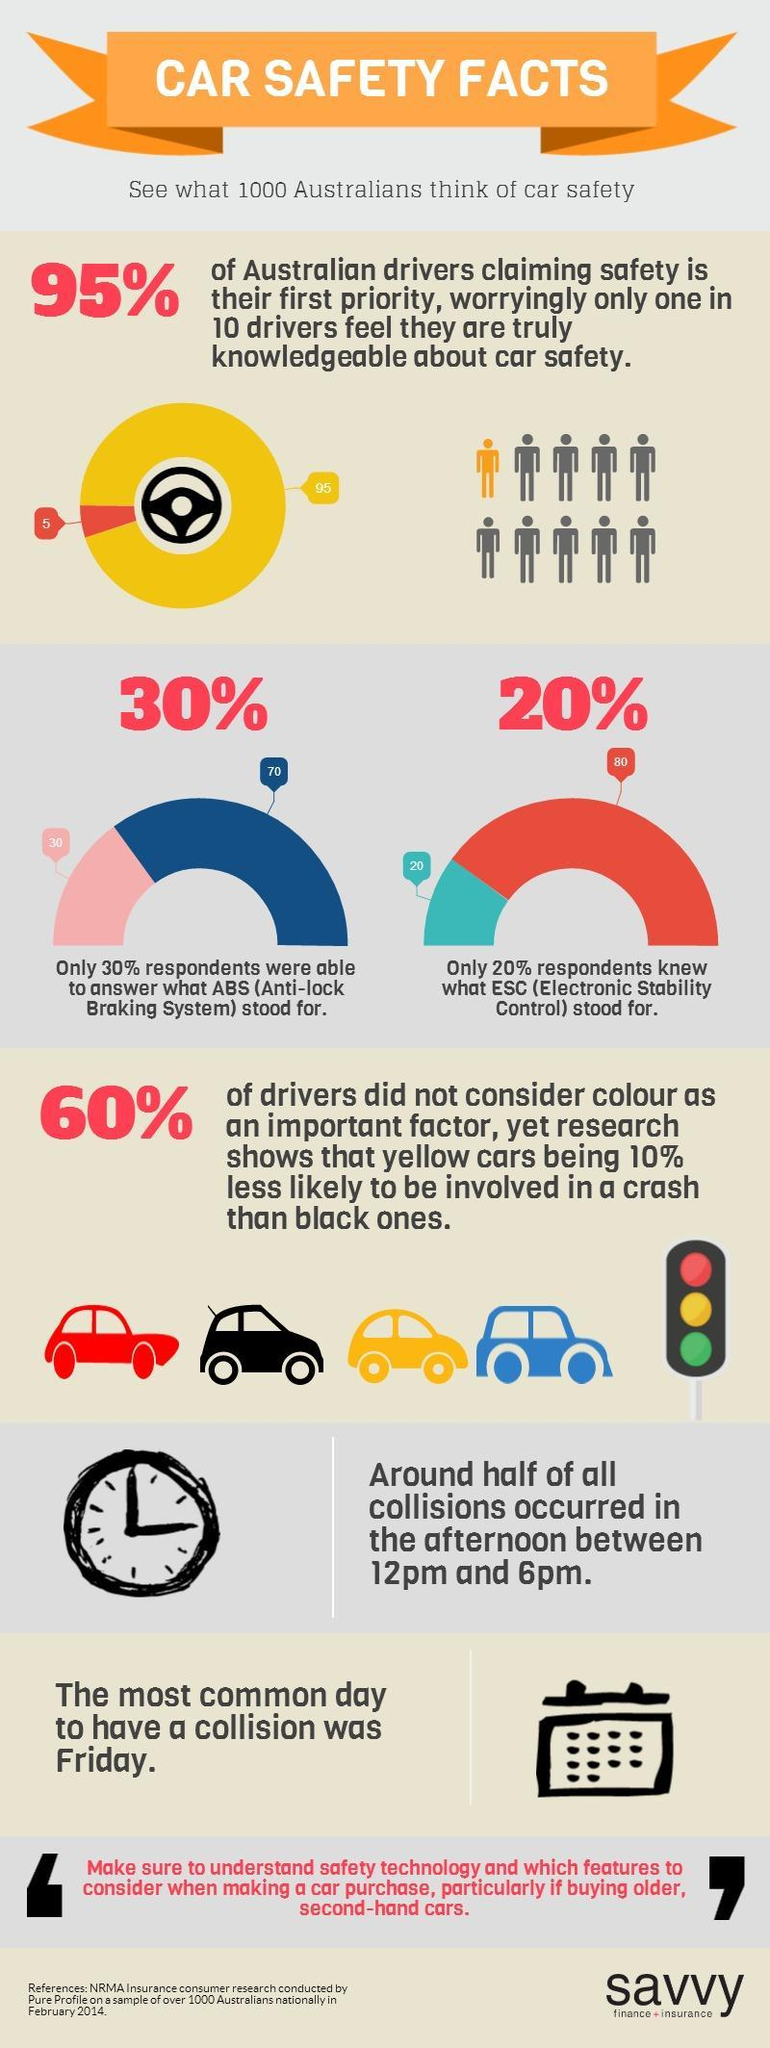What percentage of Australians were not able to answer about the Anti-lock Braking System in Cars?
Answer the question with a short phrase. 70% What percentage of Australians do not know about Electronic Stability Control in car safety? 80% What percentage of drivers considered colour as an important factor according to the research conducted over 1000 Australians in Febraury 2014? 40% 